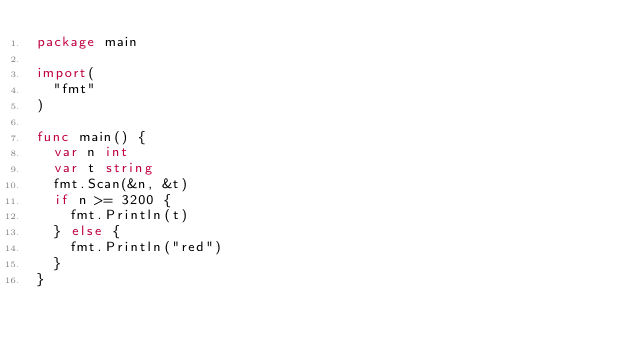<code> <loc_0><loc_0><loc_500><loc_500><_Go_>package main

import(
  "fmt"
)

func main() {
  var n int
  var t string
  fmt.Scan(&n, &t)
  if n >= 3200 {
    fmt.Println(t)
  } else {
    fmt.Println("red")
  }
}</code> 